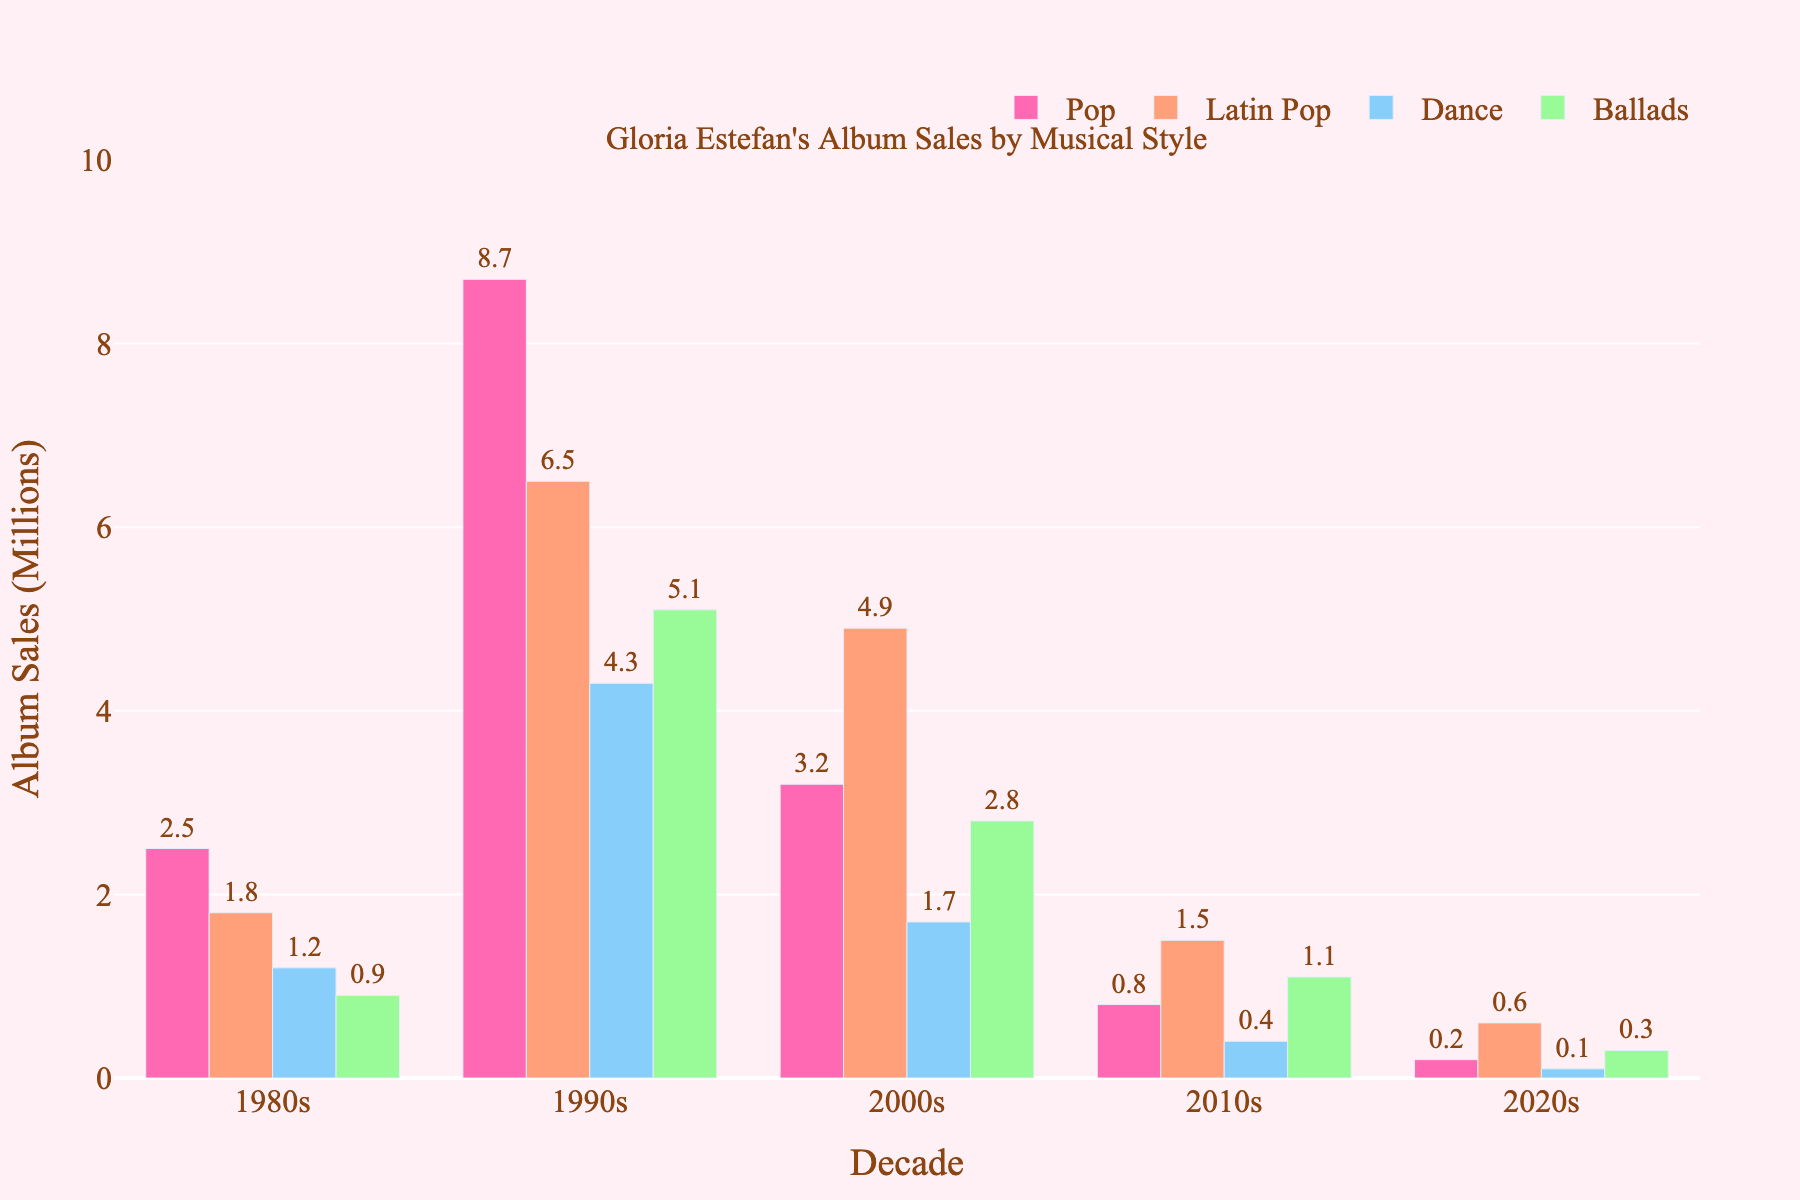What was Gloria Estefan's highest album sales decade for Latin Pop? In the figure, the Latin Pop sales for each decade are visible. The decade with the highest bar is the 1990s, showing sales of 6.5 million.
Answer: 1990s In which decade did Gloria Estefan sell the least number of Pop albums? Comparing the heights of the bars in the Pop category for all decades, the shortest bar is for the 2020s, showing sales of 0.2 million.
Answer: 2020s What is the total album sales for all musical styles in the 1990s? To find the total, sum the sales of all musical styles for the 1990s: 8.7 (Pop) + 6.5 (Latin Pop) + 4.3 (Dance) + 5.1 (Ballads) = 24.6 million.
Answer: 24.6 million How did the album sales in the 2000s for Ballads compare to Dance? By examining the chart, the bar for Ballads in the 2000s is higher than the bar for Dance, indicating more sales. Specifically, Ballads sold 2.8 million, while Dance sold 1.7 million.
Answer: Ballads had higher sales Which musical style experienced the greatest drop in sales from the 1990s to the 2010s? Calculate the difference in sales for each style between the 1990s and 2010s: 
- Pop: 8.7 - 0.8 = 7.9
- Latin Pop: 6.5 - 1.5 = 5.0
- Dance: 4.3 - 0.4 = 3.9
- Ballads: 5.1 - 1.1 = 4.0
The greatest drop is in Pop, with a decrease of 7.9 million.
Answer: Pop What is the average album sales for Dance style across all decades? Sum the album sales for Dance style across all decades and then divide by the number of decades: 
(1.2 + 4.3 + 1.7 + 0.4 + 0.1) / 5 = 7.7 / 5 = 1.54 million.
Answer: 1.54 million Which decade saw the highest sales for Ballads and what were the sales? Look at the Ballads bar heights for each decade; the highest is in the 1990s, with sales of 5.1 million.
Answer: 1990s, 5.1 million Did the Pop album sales in the 1980s exceed the total Dance album sales in the 2010s and 2020s combined? First, sum the Dance sales for the 2010s and 2020s: 0.4 + 0.1 = 0.5 million. Then compare this with the Pop sales in the 1980s, which were 2.5 million. Since 2.5 > 0.5, yes, Pop sales in the 1980s exceeded the combined Dance sales.
Answer: Yes Which musical style had the least sales in the 1980s, and what was the amount? By comparing the heights of the bars in the 1980s, the shortest is Ballads, with sales of 0.9 million.
Answer: Ballads, 0.9 million 